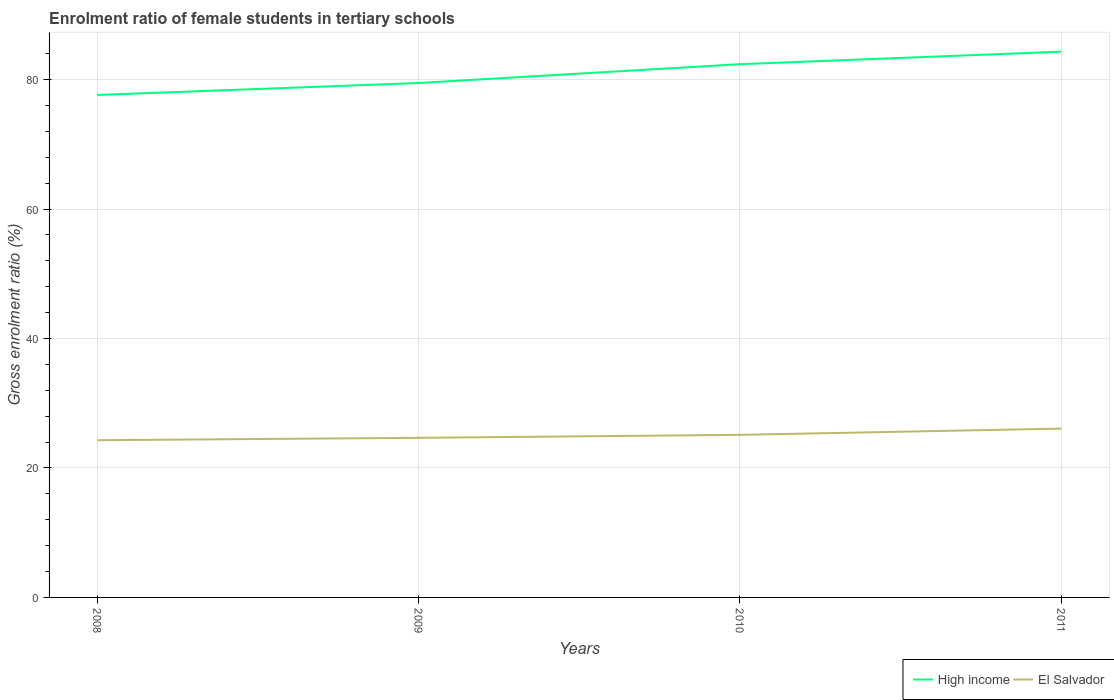Across all years, what is the maximum enrolment ratio of female students in tertiary schools in El Salvador?
Offer a terse response. 24.29. In which year was the enrolment ratio of female students in tertiary schools in El Salvador maximum?
Ensure brevity in your answer.  2008. What is the total enrolment ratio of female students in tertiary schools in El Salvador in the graph?
Keep it short and to the point. -1.43. What is the difference between the highest and the second highest enrolment ratio of female students in tertiary schools in High income?
Make the answer very short. 6.68. What is the difference between the highest and the lowest enrolment ratio of female students in tertiary schools in El Salvador?
Your answer should be compact. 2. Is the enrolment ratio of female students in tertiary schools in El Salvador strictly greater than the enrolment ratio of female students in tertiary schools in High income over the years?
Your response must be concise. Yes. How many years are there in the graph?
Your answer should be very brief. 4. How many legend labels are there?
Your answer should be compact. 2. How are the legend labels stacked?
Ensure brevity in your answer.  Horizontal. What is the title of the graph?
Your answer should be very brief. Enrolment ratio of female students in tertiary schools. Does "Paraguay" appear as one of the legend labels in the graph?
Ensure brevity in your answer.  No. What is the Gross enrolment ratio (%) of High income in 2008?
Your response must be concise. 77.63. What is the Gross enrolment ratio (%) of El Salvador in 2008?
Your answer should be very brief. 24.29. What is the Gross enrolment ratio (%) of High income in 2009?
Keep it short and to the point. 79.48. What is the Gross enrolment ratio (%) of El Salvador in 2009?
Your response must be concise. 24.66. What is the Gross enrolment ratio (%) in High income in 2010?
Your answer should be compact. 82.39. What is the Gross enrolment ratio (%) in El Salvador in 2010?
Your response must be concise. 25.12. What is the Gross enrolment ratio (%) of High income in 2011?
Your answer should be very brief. 84.32. What is the Gross enrolment ratio (%) in El Salvador in 2011?
Your answer should be very brief. 26.08. Across all years, what is the maximum Gross enrolment ratio (%) in High income?
Your response must be concise. 84.32. Across all years, what is the maximum Gross enrolment ratio (%) of El Salvador?
Your response must be concise. 26.08. Across all years, what is the minimum Gross enrolment ratio (%) of High income?
Ensure brevity in your answer.  77.63. Across all years, what is the minimum Gross enrolment ratio (%) of El Salvador?
Provide a short and direct response. 24.29. What is the total Gross enrolment ratio (%) in High income in the graph?
Provide a succinct answer. 323.82. What is the total Gross enrolment ratio (%) in El Salvador in the graph?
Your answer should be very brief. 100.15. What is the difference between the Gross enrolment ratio (%) of High income in 2008 and that in 2009?
Your answer should be compact. -1.84. What is the difference between the Gross enrolment ratio (%) in El Salvador in 2008 and that in 2009?
Give a very brief answer. -0.37. What is the difference between the Gross enrolment ratio (%) of High income in 2008 and that in 2010?
Make the answer very short. -4.75. What is the difference between the Gross enrolment ratio (%) in El Salvador in 2008 and that in 2010?
Keep it short and to the point. -0.83. What is the difference between the Gross enrolment ratio (%) of High income in 2008 and that in 2011?
Your answer should be compact. -6.68. What is the difference between the Gross enrolment ratio (%) of El Salvador in 2008 and that in 2011?
Keep it short and to the point. -1.79. What is the difference between the Gross enrolment ratio (%) of High income in 2009 and that in 2010?
Your answer should be very brief. -2.91. What is the difference between the Gross enrolment ratio (%) in El Salvador in 2009 and that in 2010?
Keep it short and to the point. -0.46. What is the difference between the Gross enrolment ratio (%) in High income in 2009 and that in 2011?
Ensure brevity in your answer.  -4.84. What is the difference between the Gross enrolment ratio (%) of El Salvador in 2009 and that in 2011?
Your response must be concise. -1.43. What is the difference between the Gross enrolment ratio (%) of High income in 2010 and that in 2011?
Ensure brevity in your answer.  -1.93. What is the difference between the Gross enrolment ratio (%) in El Salvador in 2010 and that in 2011?
Give a very brief answer. -0.96. What is the difference between the Gross enrolment ratio (%) in High income in 2008 and the Gross enrolment ratio (%) in El Salvador in 2009?
Offer a very short reply. 52.98. What is the difference between the Gross enrolment ratio (%) of High income in 2008 and the Gross enrolment ratio (%) of El Salvador in 2010?
Your answer should be compact. 52.51. What is the difference between the Gross enrolment ratio (%) of High income in 2008 and the Gross enrolment ratio (%) of El Salvador in 2011?
Ensure brevity in your answer.  51.55. What is the difference between the Gross enrolment ratio (%) in High income in 2009 and the Gross enrolment ratio (%) in El Salvador in 2010?
Provide a short and direct response. 54.36. What is the difference between the Gross enrolment ratio (%) in High income in 2009 and the Gross enrolment ratio (%) in El Salvador in 2011?
Keep it short and to the point. 53.39. What is the difference between the Gross enrolment ratio (%) in High income in 2010 and the Gross enrolment ratio (%) in El Salvador in 2011?
Provide a short and direct response. 56.3. What is the average Gross enrolment ratio (%) in High income per year?
Ensure brevity in your answer.  80.95. What is the average Gross enrolment ratio (%) in El Salvador per year?
Give a very brief answer. 25.04. In the year 2008, what is the difference between the Gross enrolment ratio (%) of High income and Gross enrolment ratio (%) of El Salvador?
Provide a short and direct response. 53.34. In the year 2009, what is the difference between the Gross enrolment ratio (%) of High income and Gross enrolment ratio (%) of El Salvador?
Offer a terse response. 54.82. In the year 2010, what is the difference between the Gross enrolment ratio (%) of High income and Gross enrolment ratio (%) of El Salvador?
Provide a succinct answer. 57.27. In the year 2011, what is the difference between the Gross enrolment ratio (%) in High income and Gross enrolment ratio (%) in El Salvador?
Provide a succinct answer. 58.23. What is the ratio of the Gross enrolment ratio (%) in High income in 2008 to that in 2009?
Make the answer very short. 0.98. What is the ratio of the Gross enrolment ratio (%) in El Salvador in 2008 to that in 2009?
Your response must be concise. 0.99. What is the ratio of the Gross enrolment ratio (%) in High income in 2008 to that in 2010?
Provide a succinct answer. 0.94. What is the ratio of the Gross enrolment ratio (%) in El Salvador in 2008 to that in 2010?
Your answer should be very brief. 0.97. What is the ratio of the Gross enrolment ratio (%) of High income in 2008 to that in 2011?
Provide a short and direct response. 0.92. What is the ratio of the Gross enrolment ratio (%) of El Salvador in 2008 to that in 2011?
Offer a terse response. 0.93. What is the ratio of the Gross enrolment ratio (%) of High income in 2009 to that in 2010?
Your answer should be very brief. 0.96. What is the ratio of the Gross enrolment ratio (%) in El Salvador in 2009 to that in 2010?
Offer a terse response. 0.98. What is the ratio of the Gross enrolment ratio (%) of High income in 2009 to that in 2011?
Your answer should be very brief. 0.94. What is the ratio of the Gross enrolment ratio (%) in El Salvador in 2009 to that in 2011?
Your answer should be compact. 0.95. What is the ratio of the Gross enrolment ratio (%) in High income in 2010 to that in 2011?
Give a very brief answer. 0.98. What is the ratio of the Gross enrolment ratio (%) of El Salvador in 2010 to that in 2011?
Your answer should be very brief. 0.96. What is the difference between the highest and the second highest Gross enrolment ratio (%) in High income?
Ensure brevity in your answer.  1.93. What is the difference between the highest and the second highest Gross enrolment ratio (%) in El Salvador?
Your answer should be compact. 0.96. What is the difference between the highest and the lowest Gross enrolment ratio (%) of High income?
Your answer should be very brief. 6.68. What is the difference between the highest and the lowest Gross enrolment ratio (%) of El Salvador?
Your answer should be very brief. 1.79. 